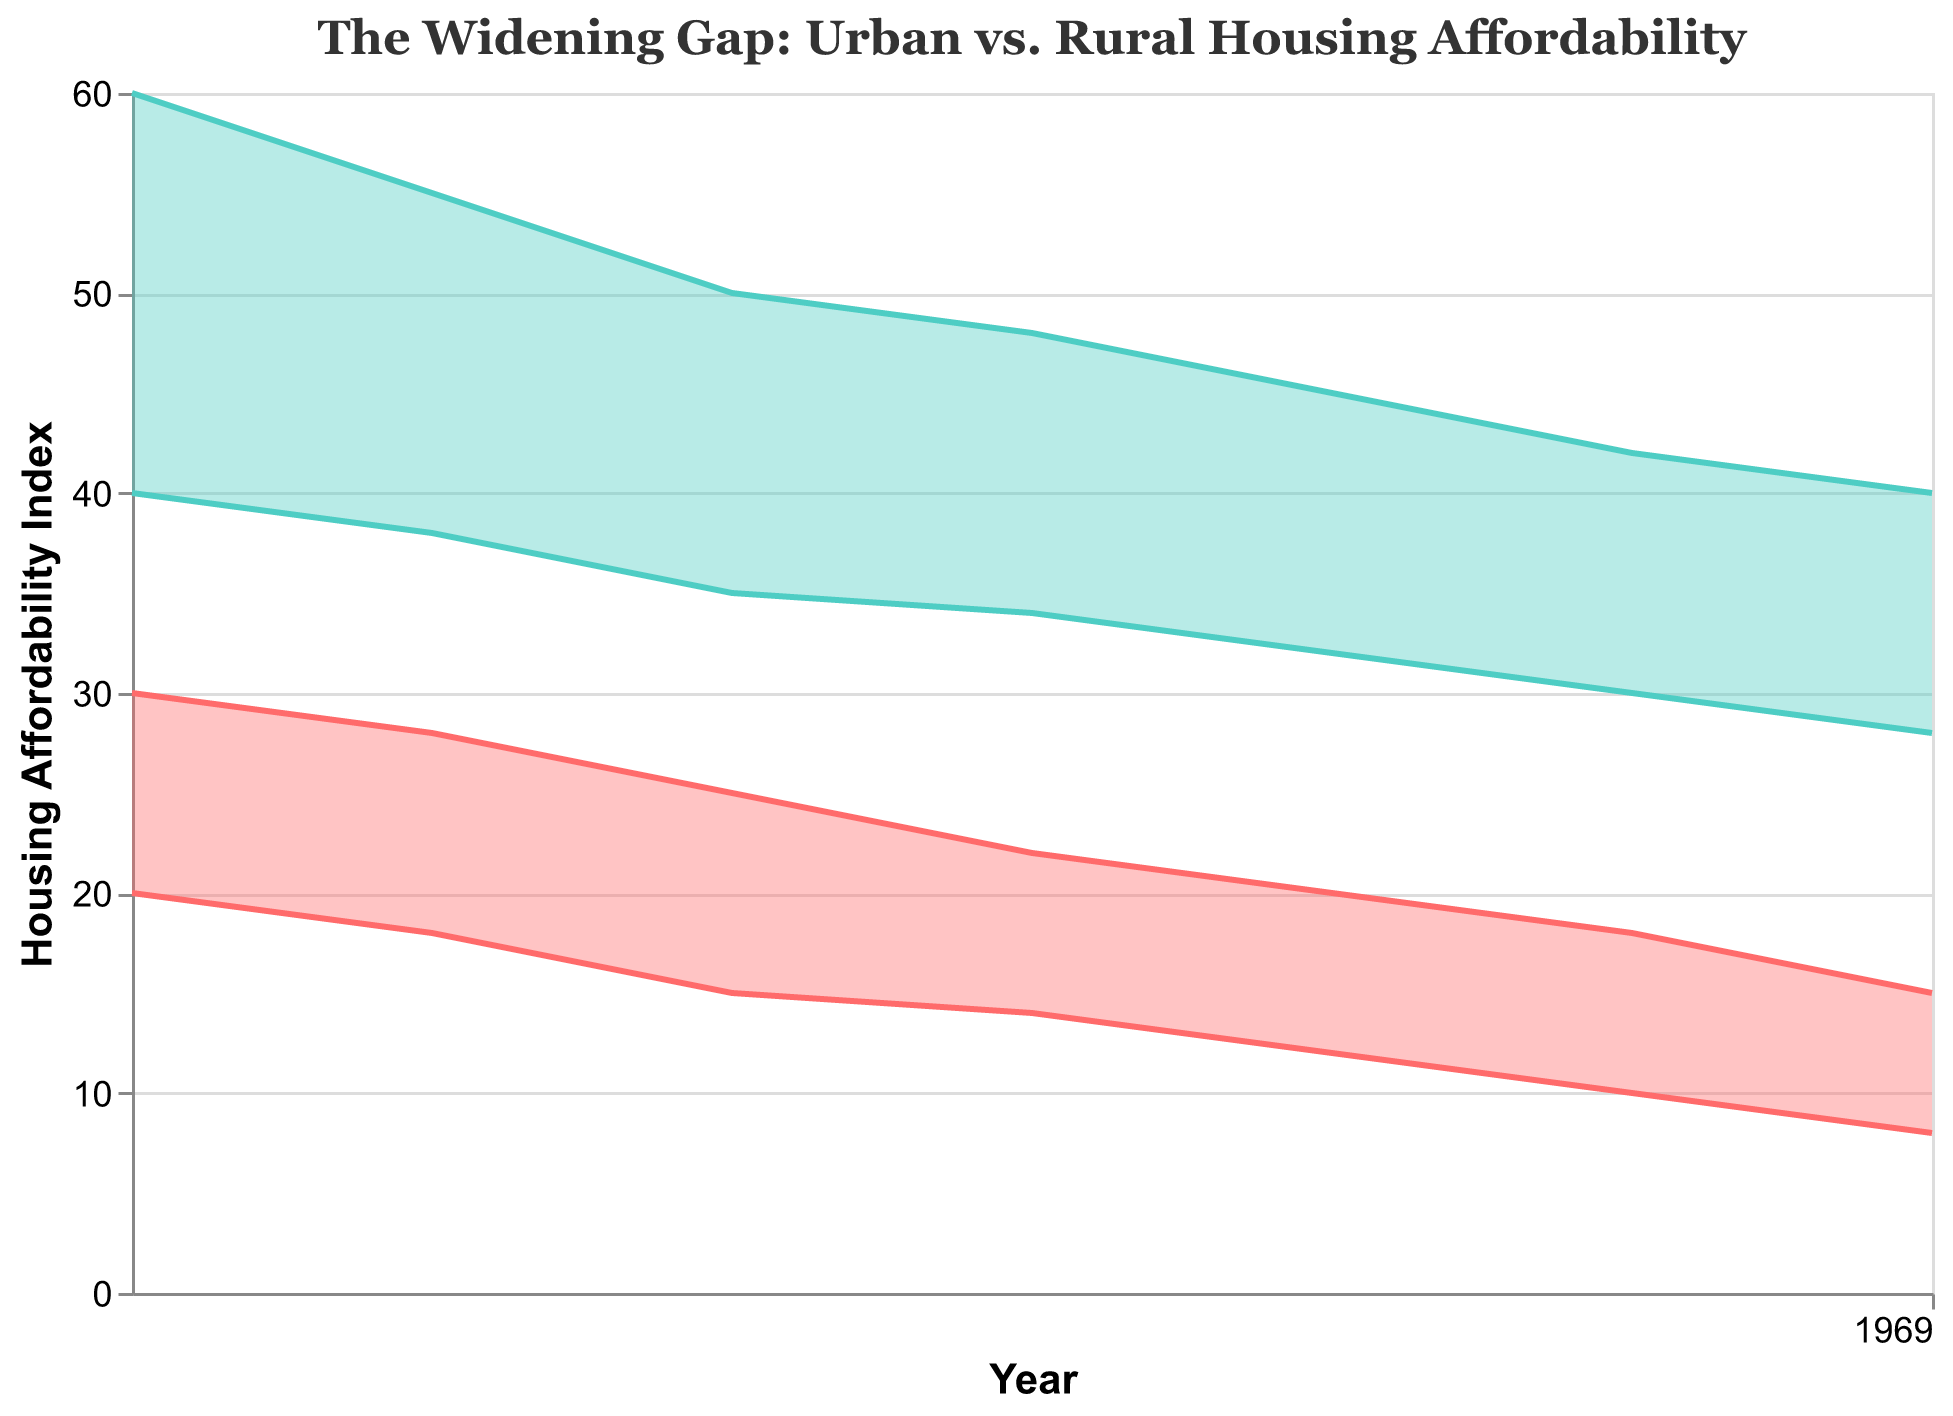**Basic**: What is the title of the figure? The title of the figure is generally at the top, which can be read as the main heading. In this case, it is specified in the code.
Answer: "The Widening Gap: Urban vs. Rural Housing Affordability" **Basic**: What are the years included in the figure? The x-axis represents the years, displaying data points from 2000 to 2030.
Answer: 2000, 2005, 2010, 2015, 2020, 2025, 2030 **Compositional**: What is the difference between Urban Min Affordability and Urban Max Affordability in 2025? According to the figure, Urban Min Affordability in 2025 is 10 and Urban Max Affordability is 18. Subtract the min value from the max value to get the difference: 18 - 10 = 8.
Answer: 8 **Compositional**: What is the average of Rural Max Affordability values for the years 2000 and 2010? Rural Max Affordability is 60 in 2000 and 50 in 2010. Adding these values: 60 + 50 = 110. The average is then calculated by dividing by the number of data points (2): 110 / 2 = 55.
Answer: 55 **Comparison**: How does Urban Max Affordability in 2000 compare to Rural Max Affordability in 2030? In the figure, Urban Max Affordability in 2000 is 30 and Rural Max Affordability in 2030 is 40. Compare these values to see that Rural Max Affordability is larger.
Answer: Rural Max Affordability in 2030 is higher **Comparison**: Which had a steeper decline over time: Urban Min Affordability or Rural Min Affordability? Urban Min Affordability decreases from 20 in 2000 to 8 in 2030, a decline of 12 points. Rural Min Affordability decreases from 40 in 2000 to 28 in 2030, a decline of 12 points. Both urban and rural min affordability have the same decline.
Answer: Both declined equally **Chart-Type Specific**: What is the range of Urban Housing Affordability in 2015? The Urban Min Affordability in 2015 is 14 and the Urban Max Affordability is 22. The range is from 14 to 22.
Answer: 14 to 22 **Chart-Type Specific**: Which has a wider range in 2020, Urban or Rural Housing Affordability? The Urban range in 2020 is from 12 to 20 (8 points), while the Rural range is from 32 to 45 (13 points). Therefore, Rural Housing Affordability has a wider range.
Answer: Rural Housing Affordability **Chart-Type Specific**: How has the gap between Rural Min and Max Affordability values changed from 2000 to 2030? In 2000, the gap is from 40 to 60 (20 points). In 2030, the gap is from 28 to 40 (12 points). The gap has decreased over time.
Answer: Decreased **Chart-Type Specific**: Is there any year where Urban Max Affordability is higher than Rural Min Affordability? By examining the maximum and minimum affordability values over the years, there is no year where Urban Max Affordability surpasses Rural Min Affordability.
Answer: No 